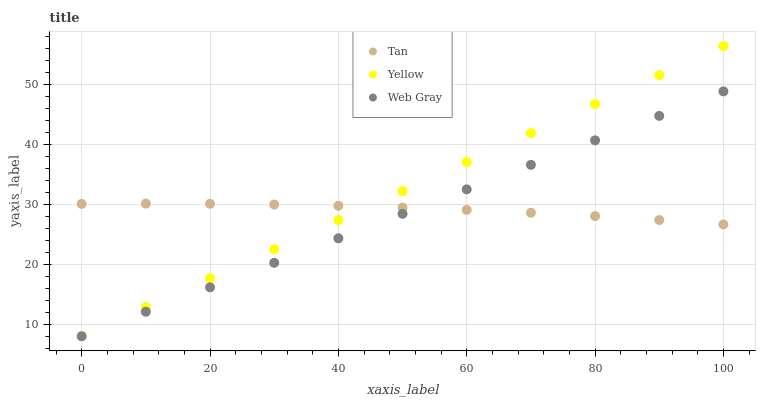Does Web Gray have the minimum area under the curve?
Answer yes or no. Yes. Does Yellow have the maximum area under the curve?
Answer yes or no. Yes. Does Yellow have the minimum area under the curve?
Answer yes or no. No. Does Web Gray have the maximum area under the curve?
Answer yes or no. No. Is Web Gray the smoothest?
Answer yes or no. Yes. Is Tan the roughest?
Answer yes or no. Yes. Is Yellow the smoothest?
Answer yes or no. No. Is Yellow the roughest?
Answer yes or no. No. Does Web Gray have the lowest value?
Answer yes or no. Yes. Does Yellow have the highest value?
Answer yes or no. Yes. Does Web Gray have the highest value?
Answer yes or no. No. Does Tan intersect Yellow?
Answer yes or no. Yes. Is Tan less than Yellow?
Answer yes or no. No. Is Tan greater than Yellow?
Answer yes or no. No. 